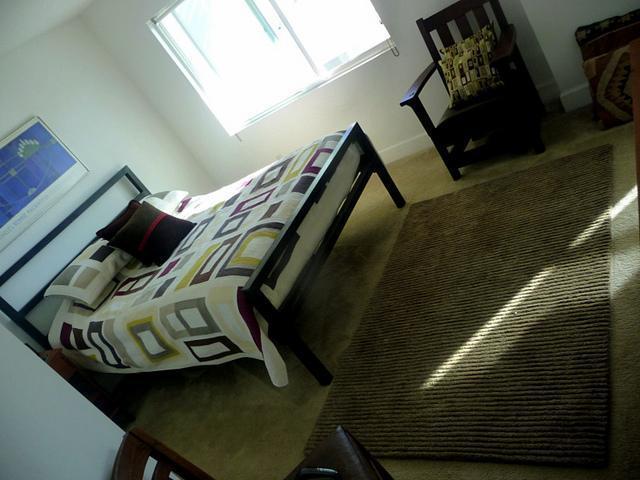What color is the painting on the wall behind the bed stand?
Select the accurate answer and provide justification: `Answer: choice
Rationale: srationale.`
Options: Red, yellow, green, blue. Answer: blue.
Rationale: The color is blue. 